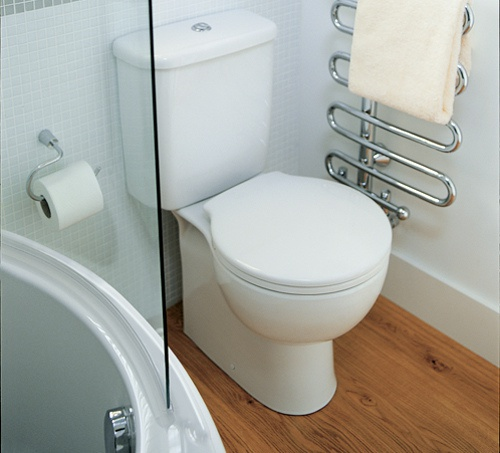Describe the objects in this image and their specific colors. I can see toilet in darkgray, lightgray, and gray tones and sink in darkgray, gray, and lightgray tones in this image. 